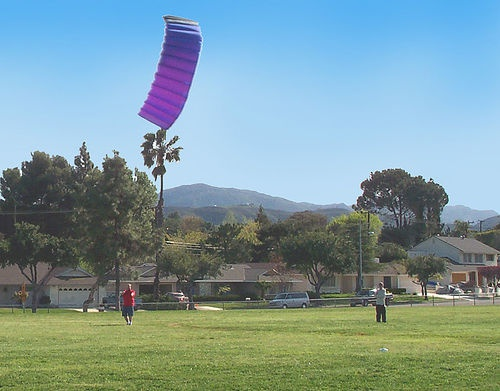Describe the objects in this image and their specific colors. I can see kite in lightblue, purple, and lavender tones, truck in lightblue, gray, and darkgray tones, truck in lightblue, gray, black, darkgray, and purple tones, people in lightblue, gray, black, darkgray, and lightgray tones, and people in lightblue, maroon, gray, and black tones in this image. 